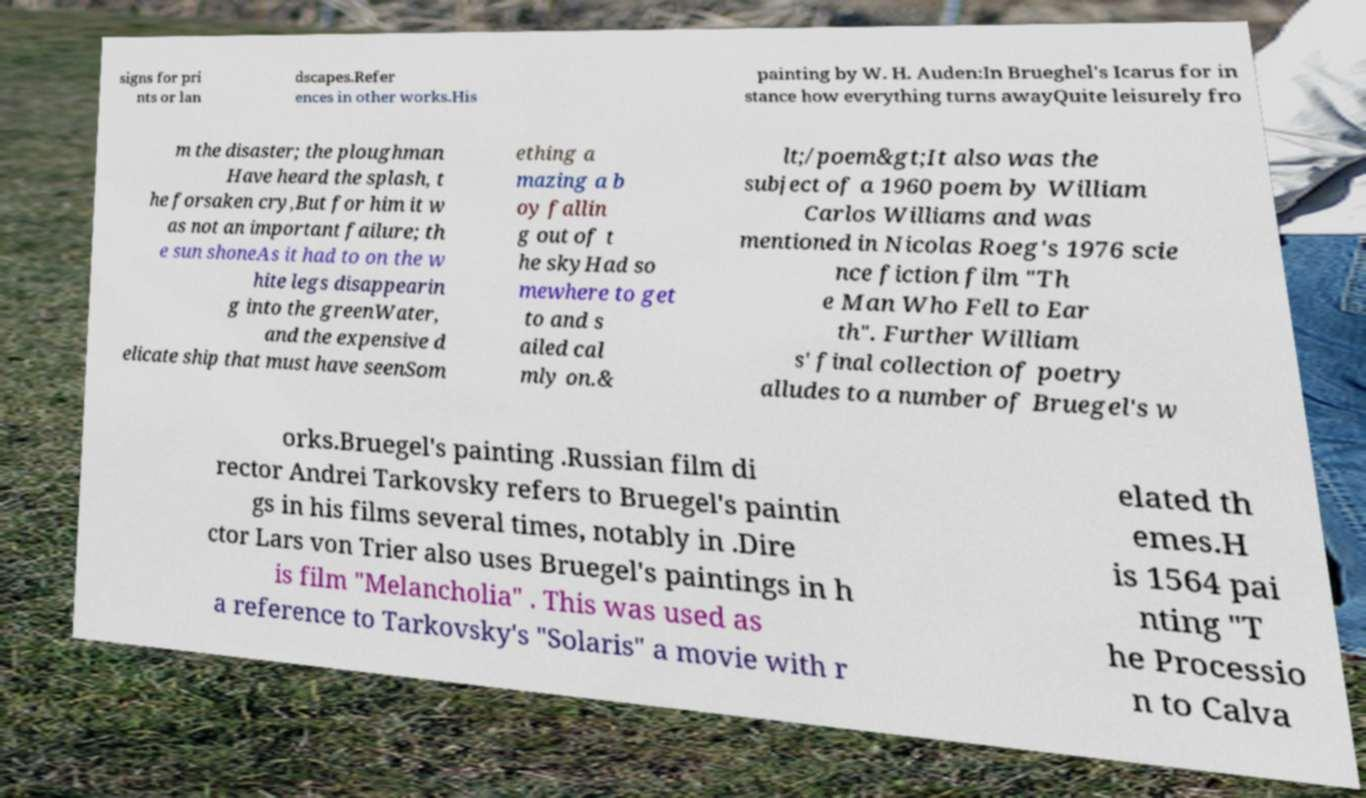Please identify and transcribe the text found in this image. signs for pri nts or lan dscapes.Refer ences in other works.His painting by W. H. Auden:In Brueghel's Icarus for in stance how everything turns awayQuite leisurely fro m the disaster; the ploughman Have heard the splash, t he forsaken cry,But for him it w as not an important failure; th e sun shoneAs it had to on the w hite legs disappearin g into the greenWater, and the expensive d elicate ship that must have seenSom ething a mazing a b oy fallin g out of t he skyHad so mewhere to get to and s ailed cal mly on.& lt;/poem&gt;It also was the subject of a 1960 poem by William Carlos Williams and was mentioned in Nicolas Roeg's 1976 scie nce fiction film "Th e Man Who Fell to Ear th". Further William s' final collection of poetry alludes to a number of Bruegel's w orks.Bruegel's painting .Russian film di rector Andrei Tarkovsky refers to Bruegel's paintin gs in his films several times, notably in .Dire ctor Lars von Trier also uses Bruegel's paintings in h is film "Melancholia" . This was used as a reference to Tarkovsky's "Solaris" a movie with r elated th emes.H is 1564 pai nting "T he Processio n to Calva 